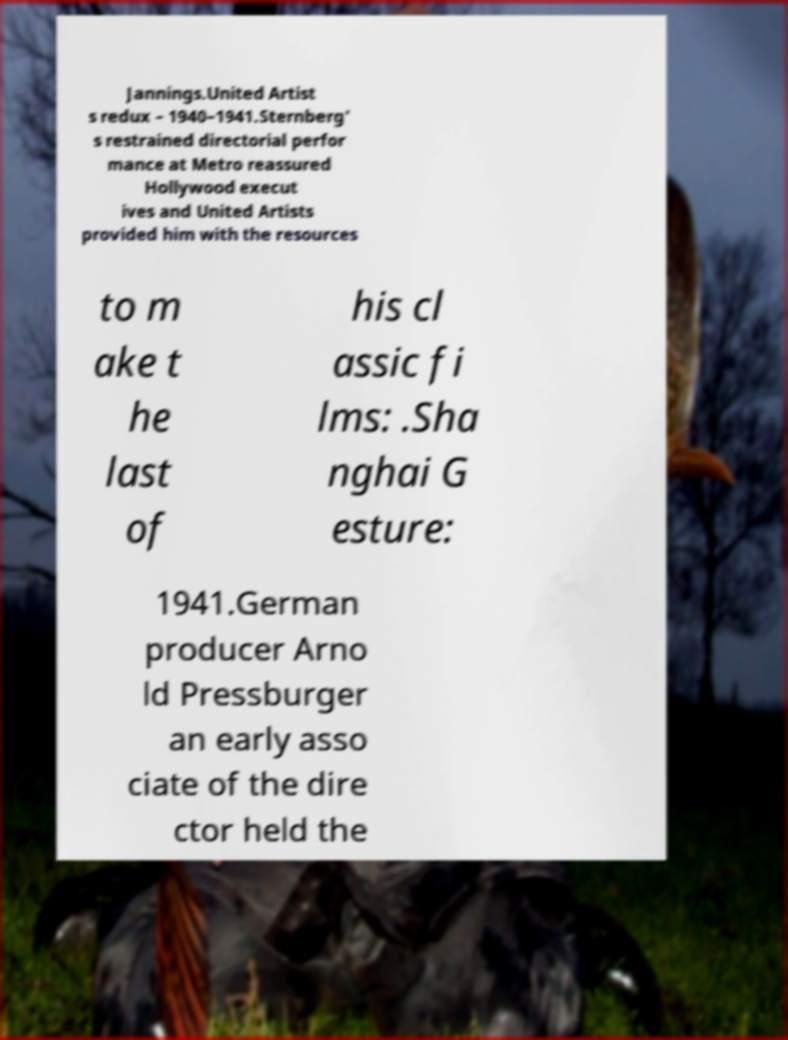For documentation purposes, I need the text within this image transcribed. Could you provide that? Jannings.United Artist s redux – 1940–1941.Sternberg' s restrained directorial perfor mance at Metro reassured Hollywood execut ives and United Artists provided him with the resources to m ake t he last of his cl assic fi lms: .Sha nghai G esture: 1941.German producer Arno ld Pressburger an early asso ciate of the dire ctor held the 